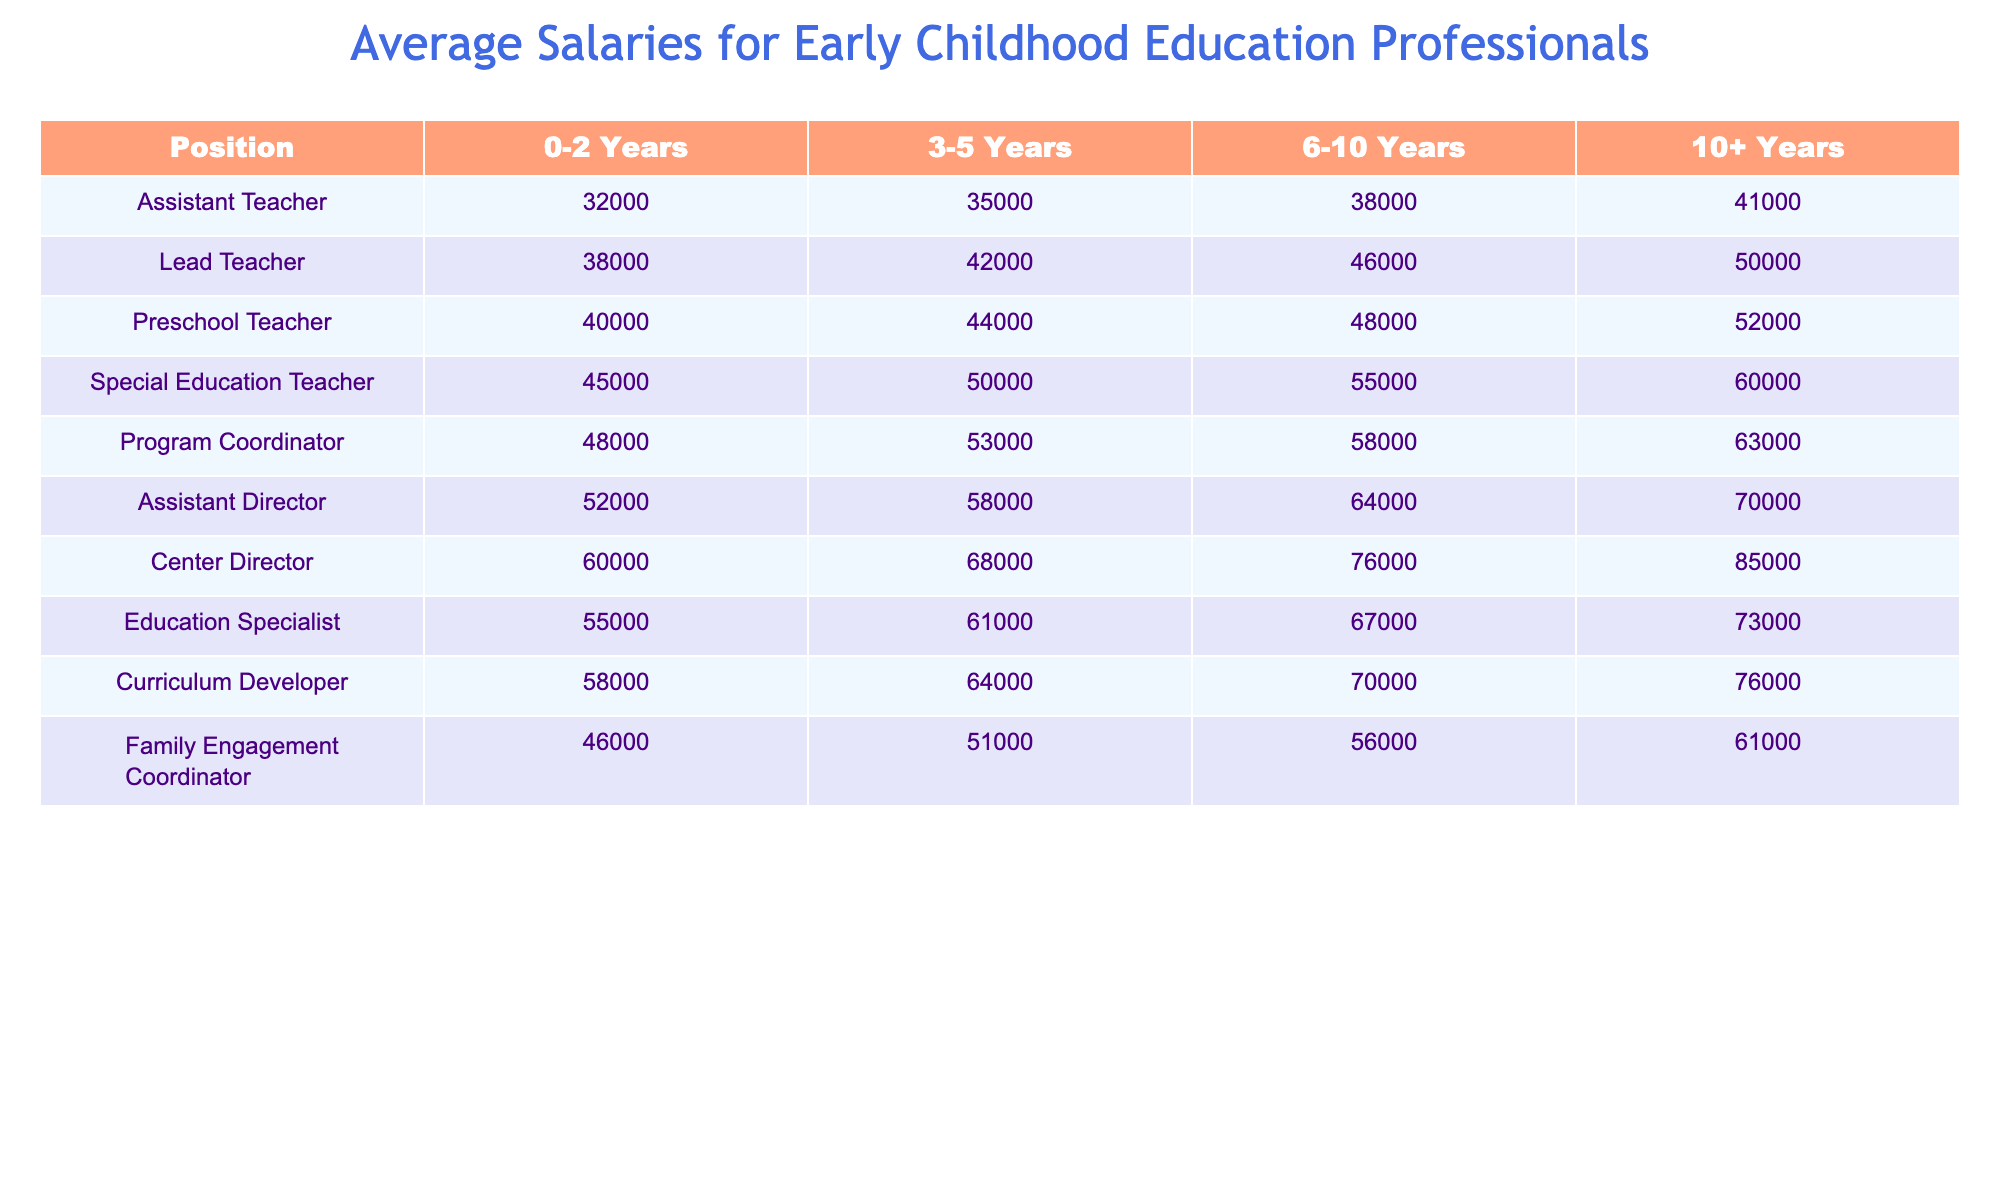What is the average salary for a Preschool Teacher with 0-2 years of experience? According to the table, the salary for a Preschool Teacher with 0-2 years of experience is listed as 40,000.
Answer: 40,000 What is the highest salary in the table for a Center Director with 10+ years of experience? The table shows that a Center Director with 10+ years of experience earns 85,000, which is the highest amount listed.
Answer: 85,000 How much more does a Special Education Teacher with 6-10 years of experience earn compared to an Assistant Teacher with the same experience? For a Special Education Teacher with 6-10 years, the salary is 55,000, and for an Assistant Teacher, it is 38,000. The difference is 55,000 - 38,000 = 17,000.
Answer: 17,000 Is the average salary for a Program Coordinator higher than that for an Education Specialist at the same experience level? A Program Coordinator with 3-5 years earns 53,000, while an Education Specialist earns 61,000. Therefore, the average salary for the Program Coordinator is not higher.
Answer: No What is the total salary of an Assistant Director and a Family Engagement Coordinator with 10+ years of experience? The Assistant Director earns 70,000 and the Family Engagement Coordinator earns 61,000 with 10+ years of experience. Their total salary is 70,000 + 61,000 = 131,000.
Answer: 131,000 Is there a position where the salary does not increase from 3-5 years to 6-10 years of experience? By comparing the salaries: Assistant Teacher, Lead Teacher, Preschool Teacher, and Special Education Teacher all show increases from 3-5 to 6-10 years; no positions have the same salary across these experience levels.
Answer: No What is the average salary increase for a Lead Teacher from 0-2 years to 10+ years? A Lead Teacher earns 38,000 with 0-2 years and 50,000 with 10+ years. The increase is 50,000 - 38,000 = 12,000, making the average increase 12,000 over 10 years.
Answer: 12,000 Which position has the lowest salary increase from 0-2 years to 3-5 years of experience? By examining the data, the Assistant Teacher increases from 32,000 to 35,000, a rise of 3,000. This is the smallest increase compared to other positions.
Answer: Assistant Teacher How does the salary of a Curriculum Developer compare to that of a Center Director with 6-10 years of experience? The Curriculum Developer earns 70,000 with 6-10 years, while a Center Director earns 76,000 at the same experience level, showing that the latter earns more.
Answer: Center Director earns more What is the total salary for all professionals with 10+ years of experience? To find the total, sum all the salaries for positions with 10+ years: 41,000 + 50,000 + 52,000 + 60,000 + 63,000 + 70,000 + 85,000 + 73,000 + 76,000 + 61,000 =  590,000.
Answer: 590,000 